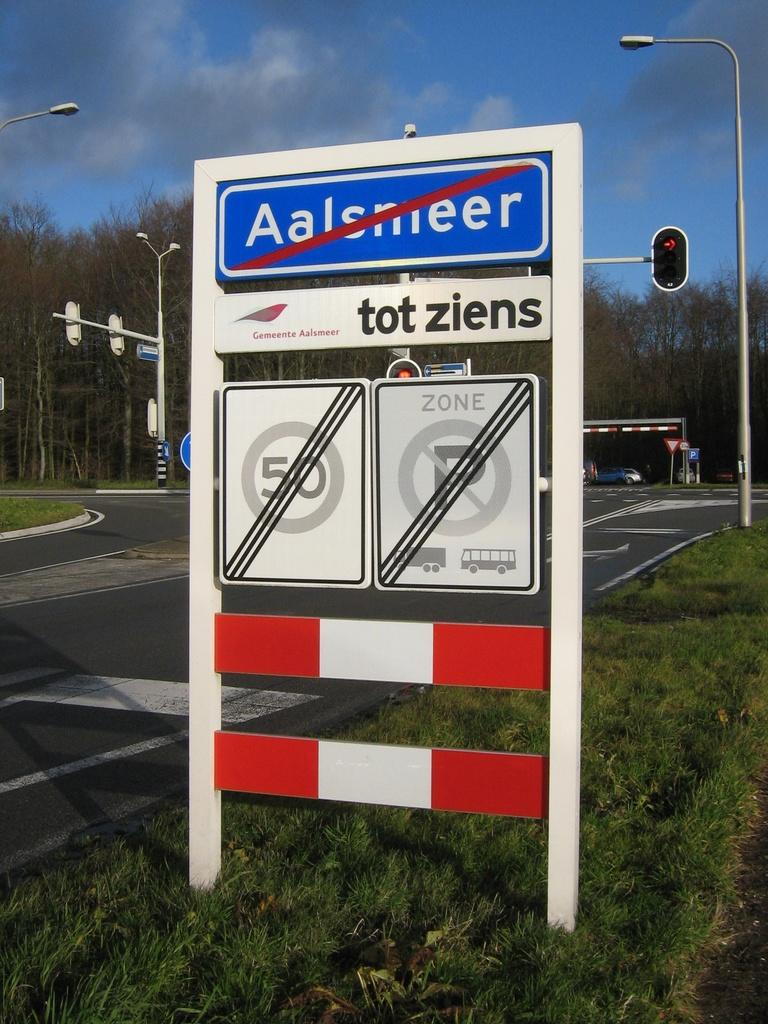<image>
Create a compact narrative representing the image presented. A sign for Aalsmeer with a line for it, 50 speed limit and no parking zone. 